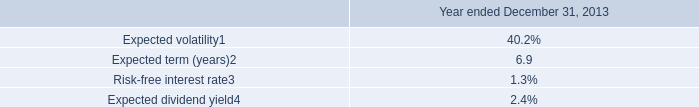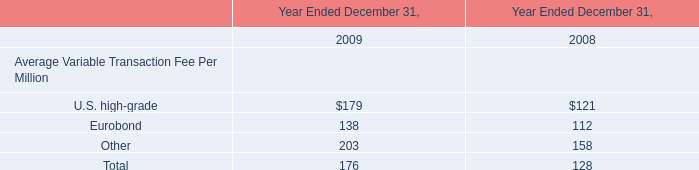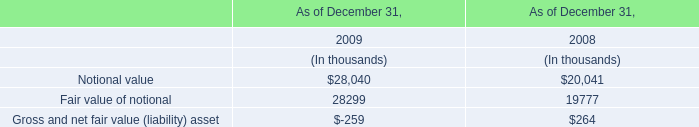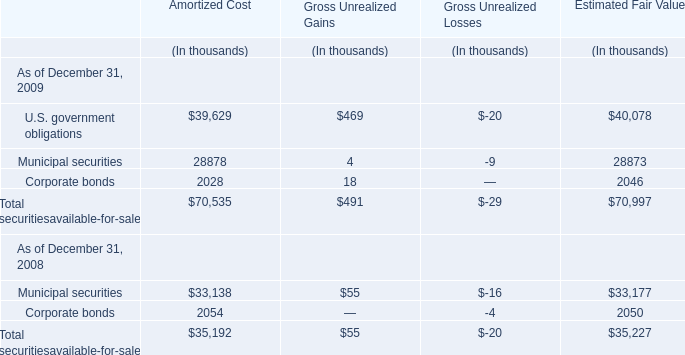What is the Total securities available-for-sale at Estimated Fair Value as of December 31, 2009 ? (in thousand) 
Answer: 70997. 